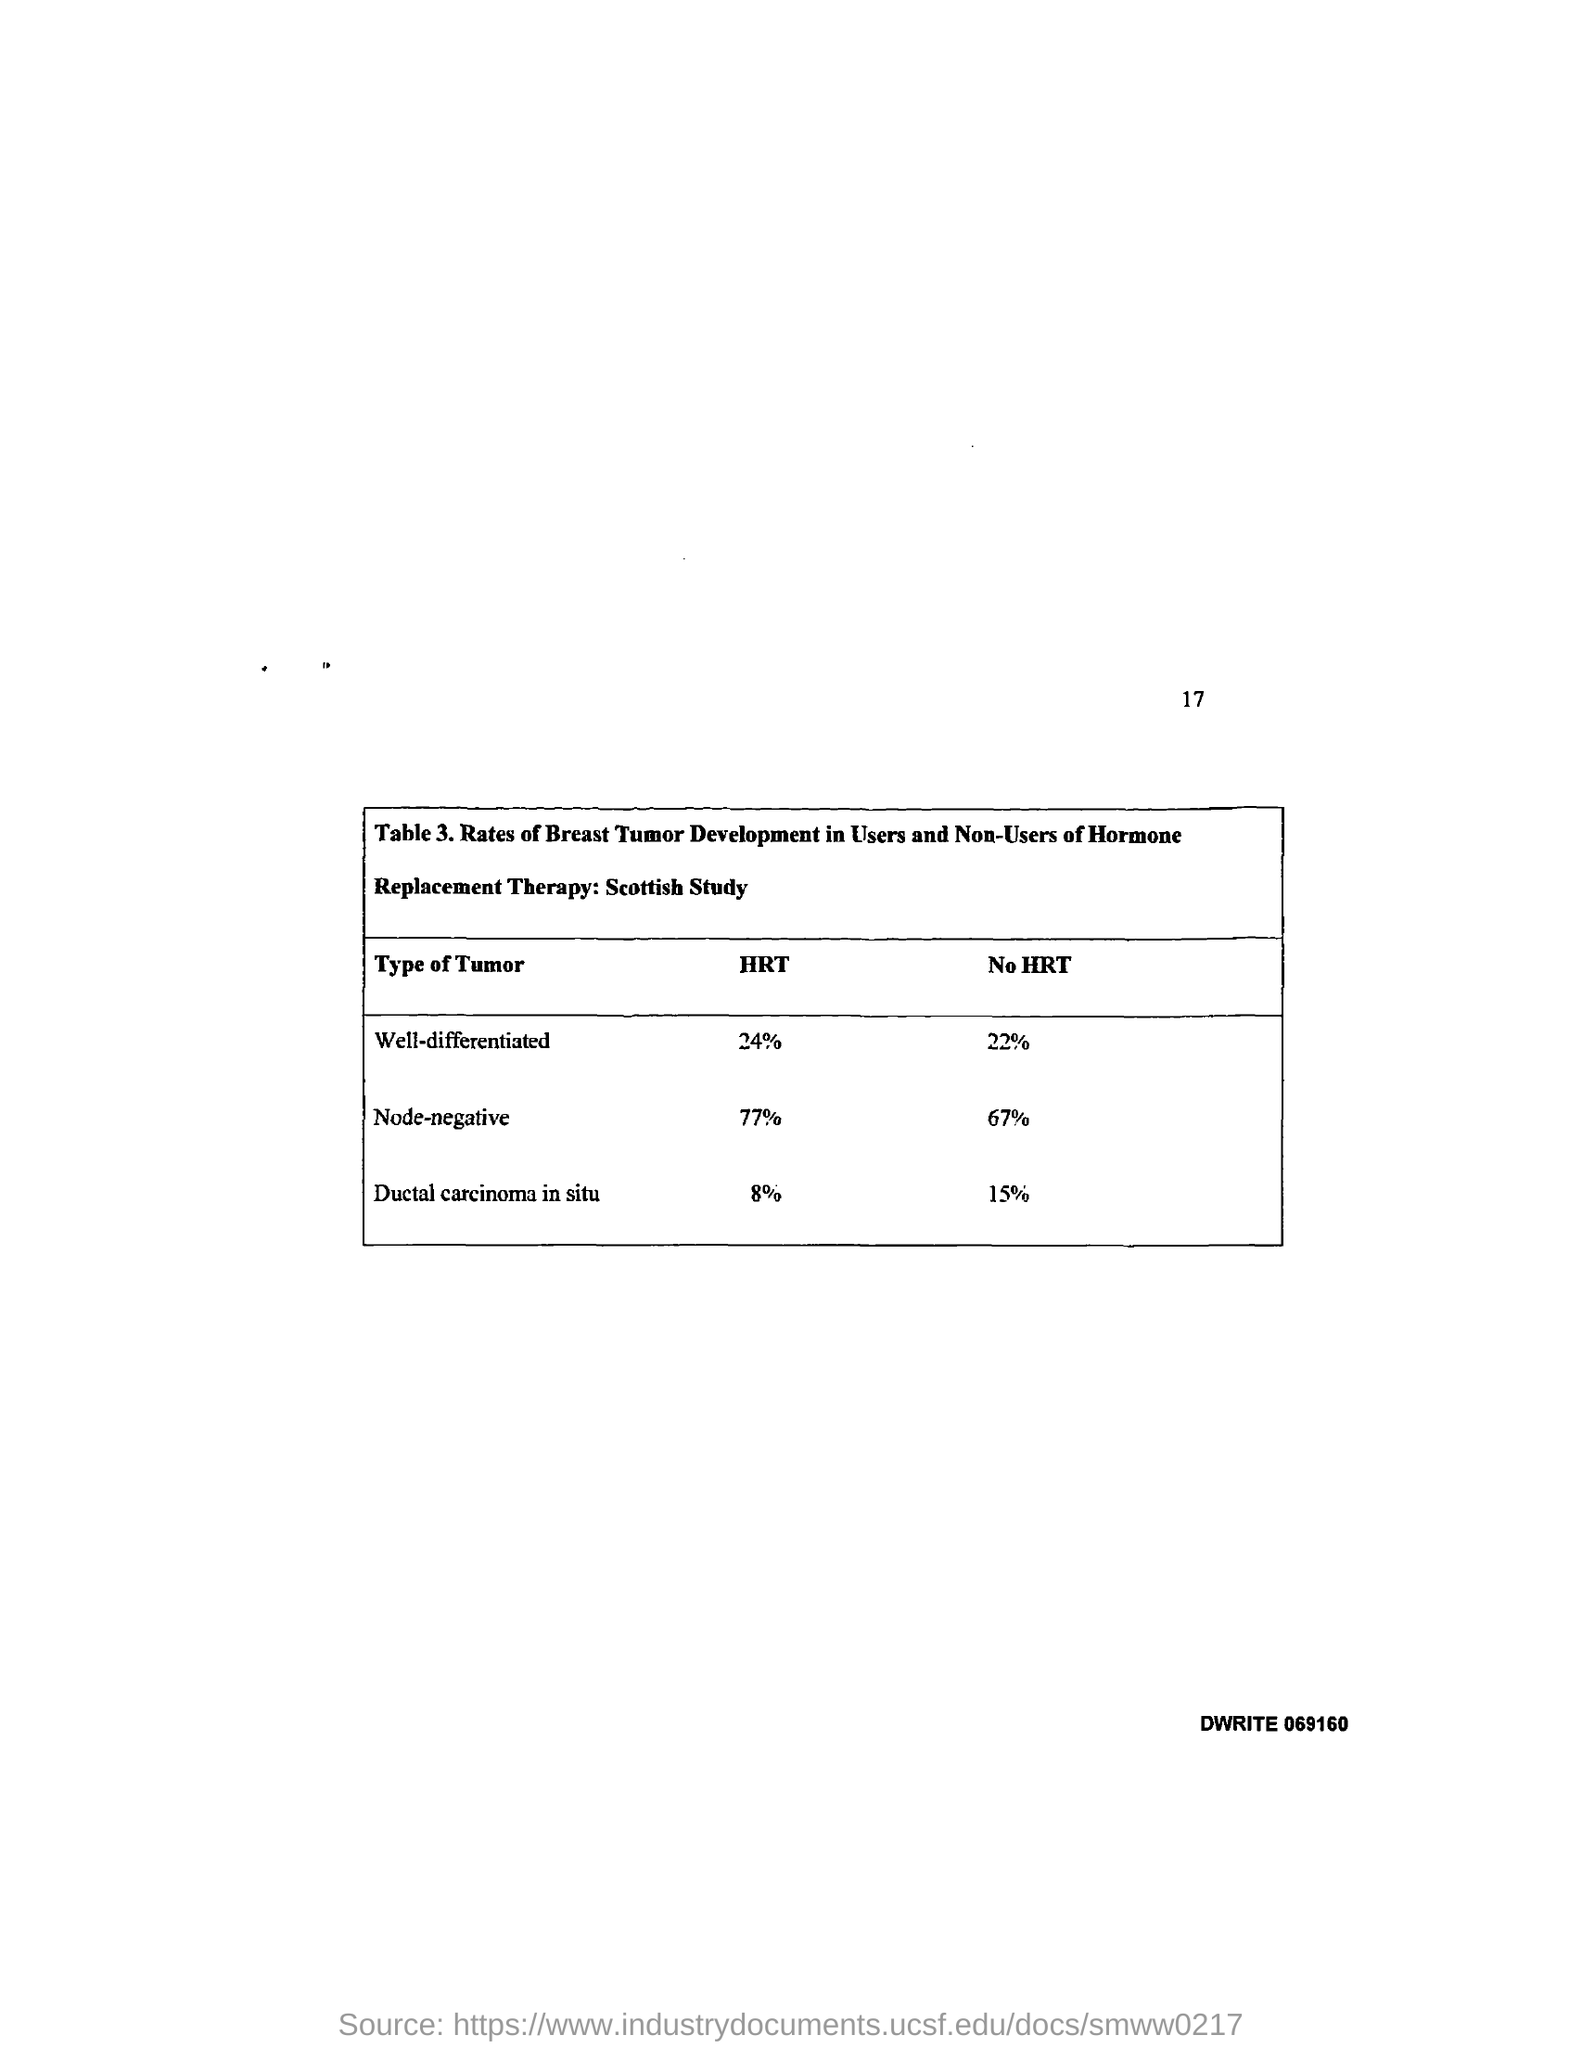List a handful of essential elements in this visual. A well differentiated tumor has developed in individuals with 24% HRT. A tumor, specifically one related to hormone replacement therapy (HRT) and having a development rate of 77%, is considered node-negative. The page number mentioned in this document is 17. 